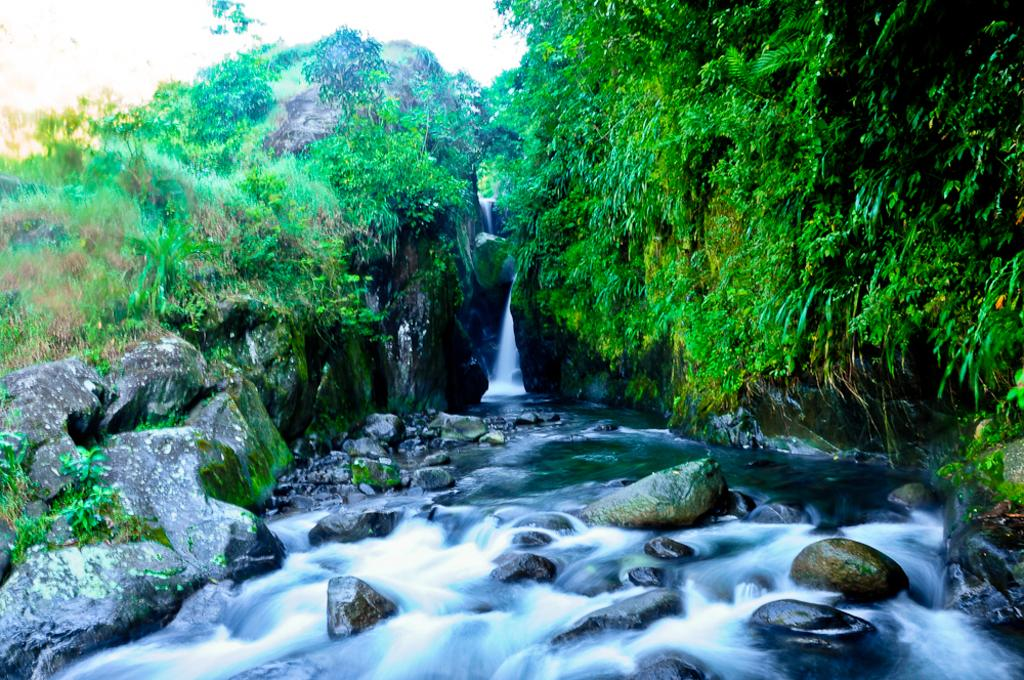What type of natural features can be seen in the image? There are rocks, hills, plants, and trees visible in the image. What else can be seen in the image besides the natural features? There is water visible in the image. Can you describe the vegetation in the image? The image contains plants and trees. How does the pickle compare to the rocks in the image? There is no pickle present in the image, so it cannot be compared to the rocks. 